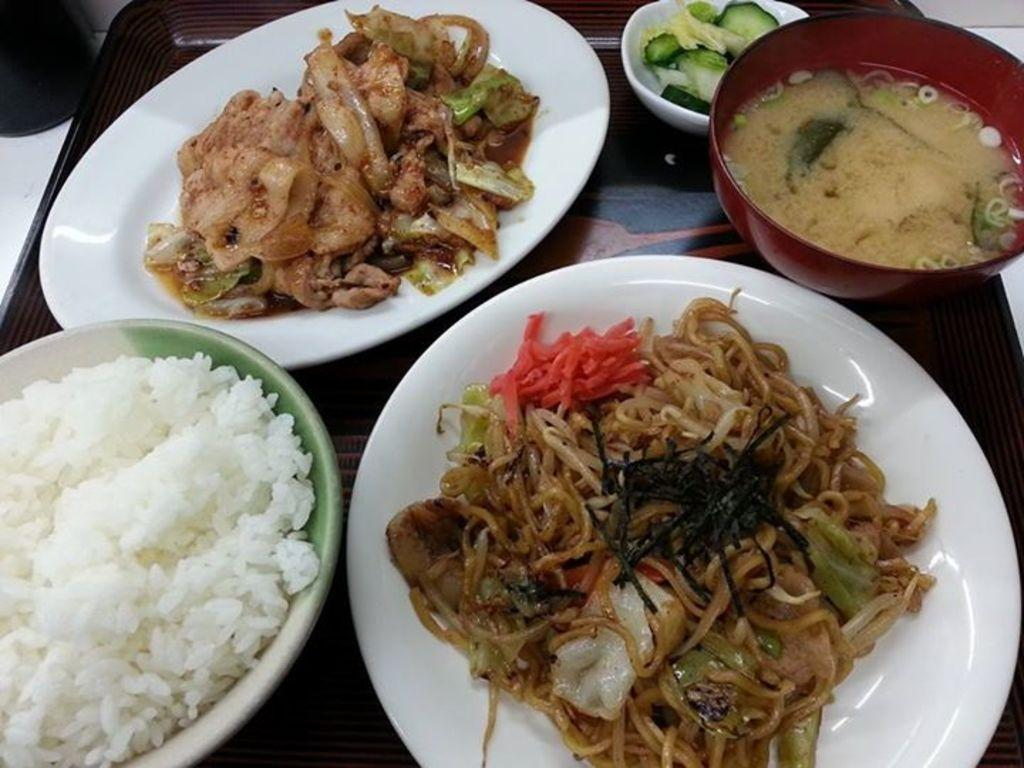What type of containers are holding food items in the image? There are plates and bowls holding food items in the image. Where are the plates and bowls located? The plates and bowls are on a tray in the image. What is the tray resting on in the image? The tray is on a table in the image. Can you see a ghost holding a rose in the image? No, there is no ghost or rose present in the image. 